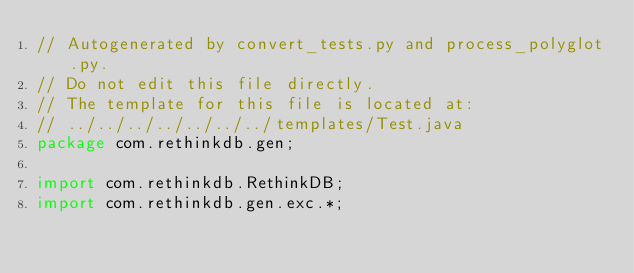Convert code to text. <code><loc_0><loc_0><loc_500><loc_500><_Java_>// Autogenerated by convert_tests.py and process_polyglot.py.
// Do not edit this file directly.
// The template for this file is located at:
// ../../../../../../../templates/Test.java
package com.rethinkdb.gen;

import com.rethinkdb.RethinkDB;
import com.rethinkdb.gen.exc.*;</code> 